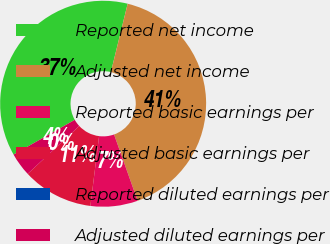<chart> <loc_0><loc_0><loc_500><loc_500><pie_chart><fcel>Reported net income<fcel>Adjusted net income<fcel>Reported basic earnings per<fcel>Adjusted basic earnings per<fcel>Reported diluted earnings per<fcel>Adjusted diluted earnings per<nl><fcel>37.04%<fcel>40.74%<fcel>7.41%<fcel>11.11%<fcel>0.0%<fcel>3.7%<nl></chart> 